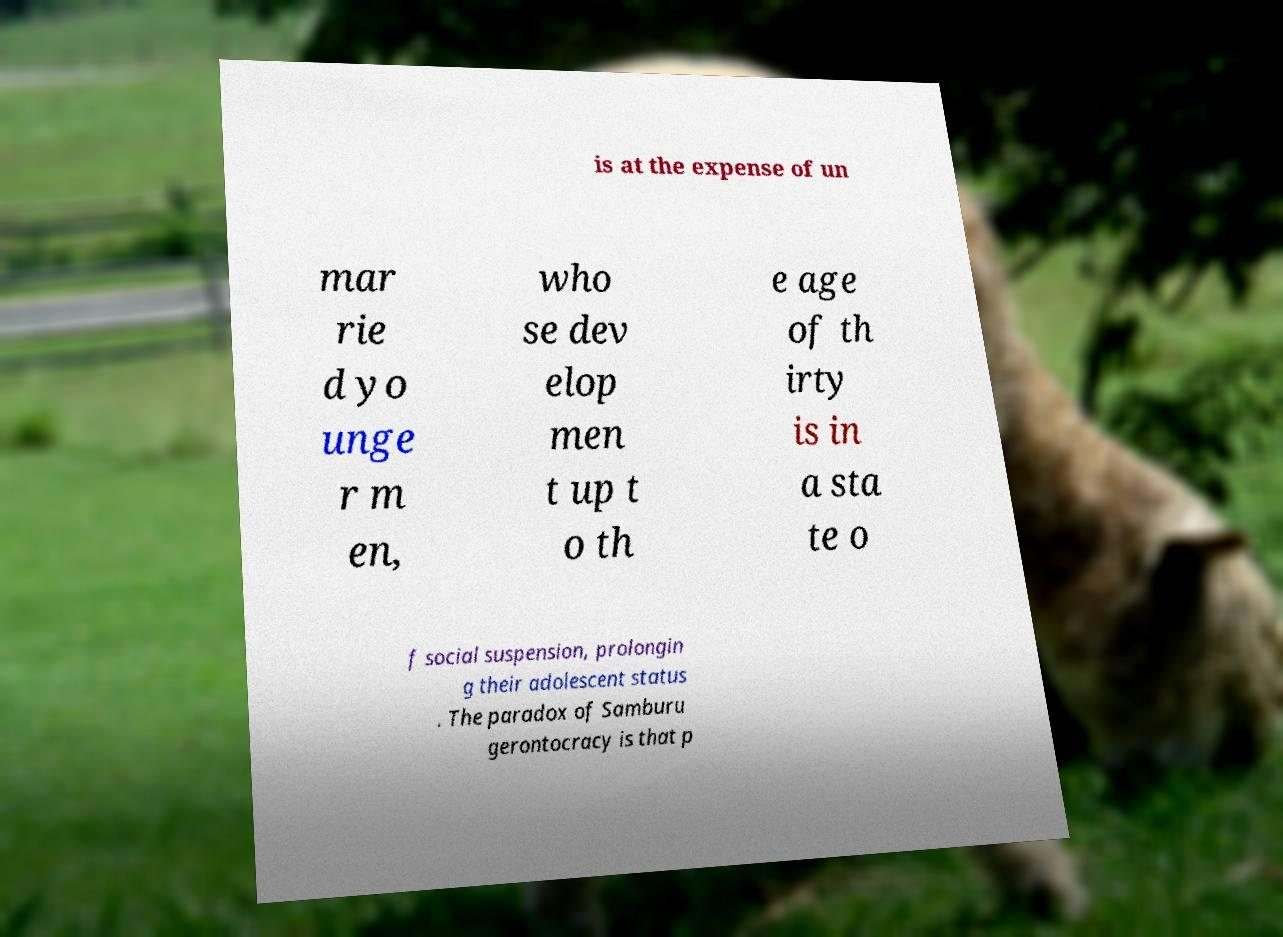There's text embedded in this image that I need extracted. Can you transcribe it verbatim? is at the expense of un mar rie d yo unge r m en, who se dev elop men t up t o th e age of th irty is in a sta te o f social suspension, prolongin g their adolescent status . The paradox of Samburu gerontocracy is that p 